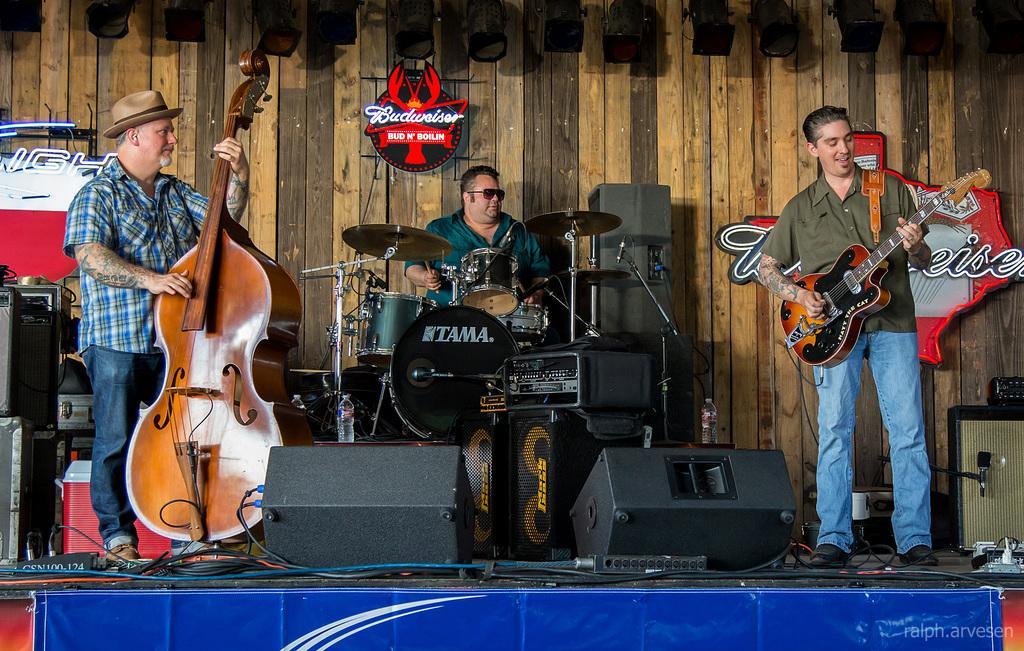How would you summarize this image in a sentence or two? There is a man who is playing guitar. Here we can see a man who is holding a guitar and he wear a cap. He is sitting on the chair and playing drums. On the background there is a wall and this is board. Here we can see some musical instruments. 